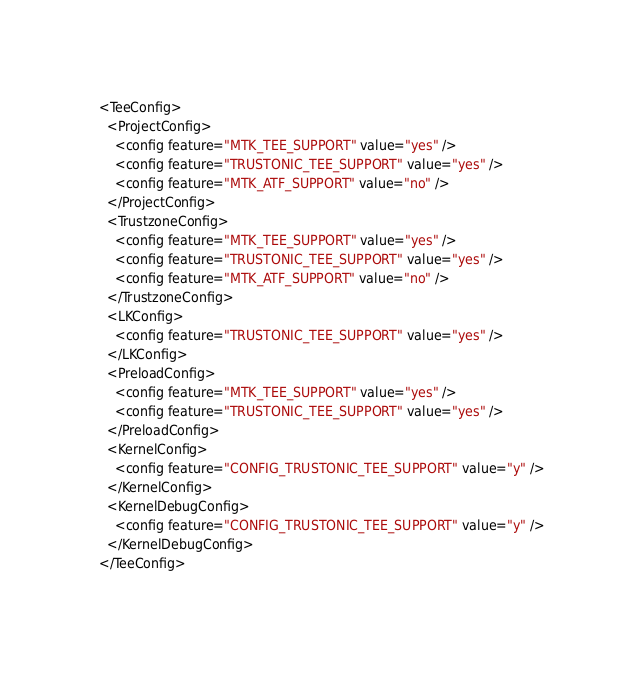Convert code to text. <code><loc_0><loc_0><loc_500><loc_500><_XML_><TeeConfig>
  <ProjectConfig>
    <config feature="MTK_TEE_SUPPORT" value="yes" />
    <config feature="TRUSTONIC_TEE_SUPPORT" value="yes" />
    <config feature="MTK_ATF_SUPPORT" value="no" />
  </ProjectConfig>
  <TrustzoneConfig>
    <config feature="MTK_TEE_SUPPORT" value="yes" />
    <config feature="TRUSTONIC_TEE_SUPPORT" value="yes" />
    <config feature="MTK_ATF_SUPPORT" value="no" />
  </TrustzoneConfig>
  <LKConfig>
    <config feature="TRUSTONIC_TEE_SUPPORT" value="yes" />
  </LKConfig>
  <PreloadConfig>
    <config feature="MTK_TEE_SUPPORT" value="yes" />
    <config feature="TRUSTONIC_TEE_SUPPORT" value="yes" />
  </PreloadConfig>
  <KernelConfig>
    <config feature="CONFIG_TRUSTONIC_TEE_SUPPORT" value="y" />
  </KernelConfig>
  <KernelDebugConfig>
    <config feature="CONFIG_TRUSTONIC_TEE_SUPPORT" value="y" />
  </KernelDebugConfig>
</TeeConfig>
</code> 